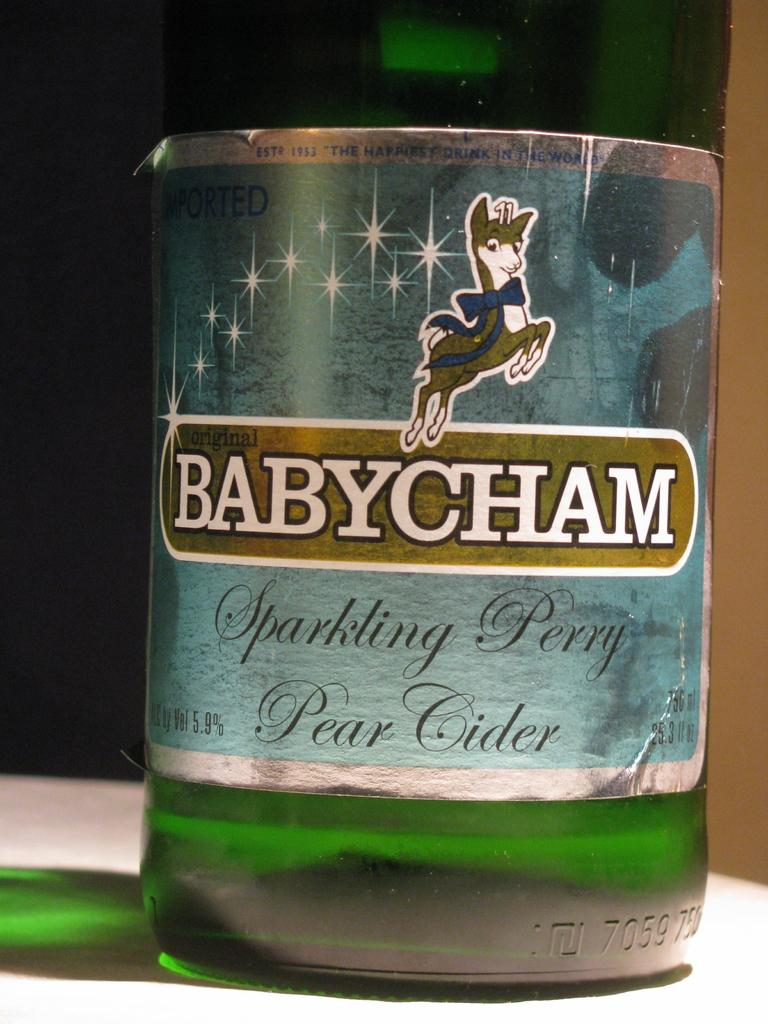What object can be seen in the image? There is a bottle in the image. Where is the bottle located? The bottle is on a table. How many pigs are sitting at the table with the bottle in the image? There are no pigs present in the image. What type of haircut does the bottle have in the image? The bottle does not have a haircut, as it is an inanimate object. 